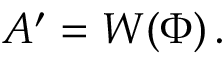<formula> <loc_0><loc_0><loc_500><loc_500>A ^ { \prime } = W \, \left ( \Phi \right ) .</formula> 